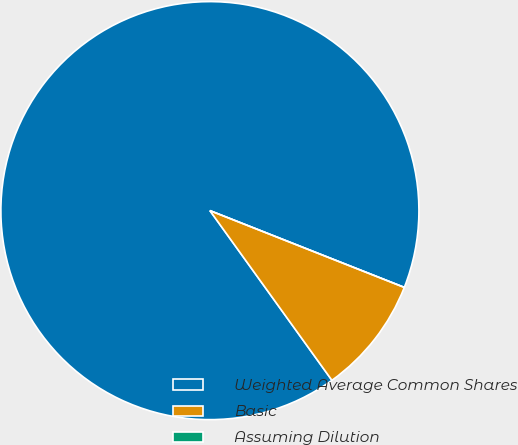Convert chart. <chart><loc_0><loc_0><loc_500><loc_500><pie_chart><fcel>Weighted Average Common Shares<fcel>Basic<fcel>Assuming Dilution<nl><fcel>90.91%<fcel>9.09%<fcel>0.0%<nl></chart> 